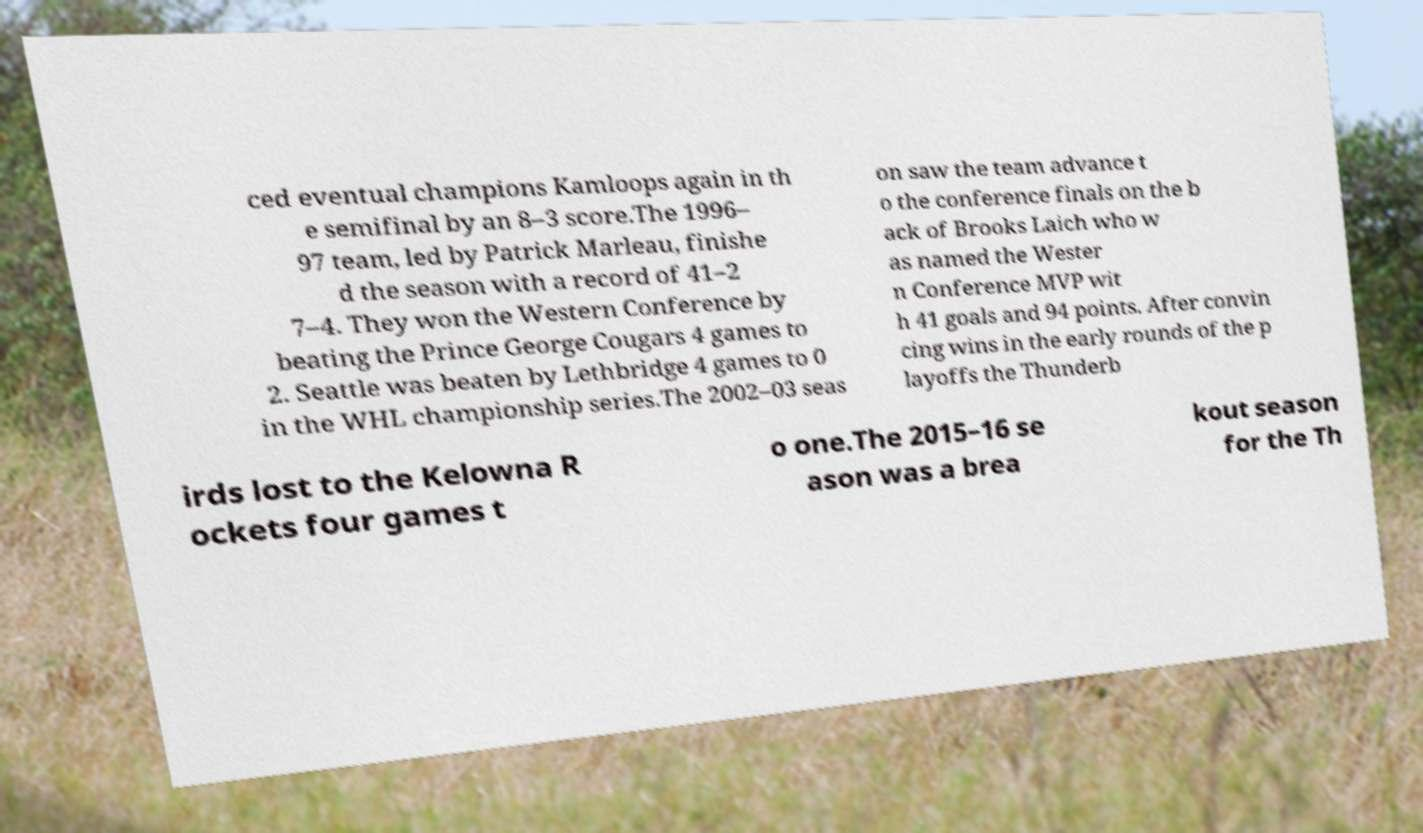I need the written content from this picture converted into text. Can you do that? ced eventual champions Kamloops again in th e semifinal by an 8–3 score.The 1996– 97 team, led by Patrick Marleau, finishe d the season with a record of 41–2 7–4. They won the Western Conference by beating the Prince George Cougars 4 games to 2. Seattle was beaten by Lethbridge 4 games to 0 in the WHL championship series.The 2002–03 seas on saw the team advance t o the conference finals on the b ack of Brooks Laich who w as named the Wester n Conference MVP wit h 41 goals and 94 points. After convin cing wins in the early rounds of the p layoffs the Thunderb irds lost to the Kelowna R ockets four games t o one.The 2015–16 se ason was a brea kout season for the Th 